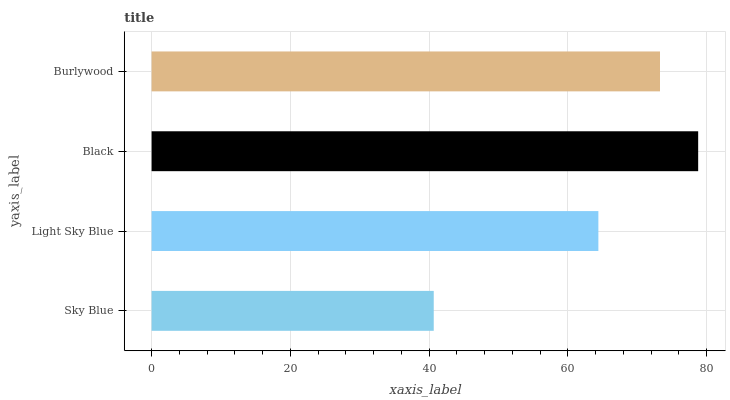Is Sky Blue the minimum?
Answer yes or no. Yes. Is Black the maximum?
Answer yes or no. Yes. Is Light Sky Blue the minimum?
Answer yes or no. No. Is Light Sky Blue the maximum?
Answer yes or no. No. Is Light Sky Blue greater than Sky Blue?
Answer yes or no. Yes. Is Sky Blue less than Light Sky Blue?
Answer yes or no. Yes. Is Sky Blue greater than Light Sky Blue?
Answer yes or no. No. Is Light Sky Blue less than Sky Blue?
Answer yes or no. No. Is Burlywood the high median?
Answer yes or no. Yes. Is Light Sky Blue the low median?
Answer yes or no. Yes. Is Light Sky Blue the high median?
Answer yes or no. No. Is Black the low median?
Answer yes or no. No. 